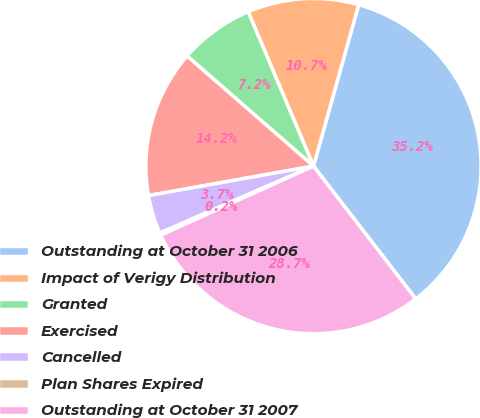Convert chart. <chart><loc_0><loc_0><loc_500><loc_500><pie_chart><fcel>Outstanding at October 31 2006<fcel>Impact of Verigy Distribution<fcel>Granted<fcel>Exercised<fcel>Cancelled<fcel>Plan Shares Expired<fcel>Outstanding at October 31 2007<nl><fcel>35.21%<fcel>10.72%<fcel>7.22%<fcel>14.22%<fcel>3.72%<fcel>0.23%<fcel>28.68%<nl></chart> 